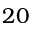Convert formula to latex. <formula><loc_0><loc_0><loc_500><loc_500>2 0</formula> 